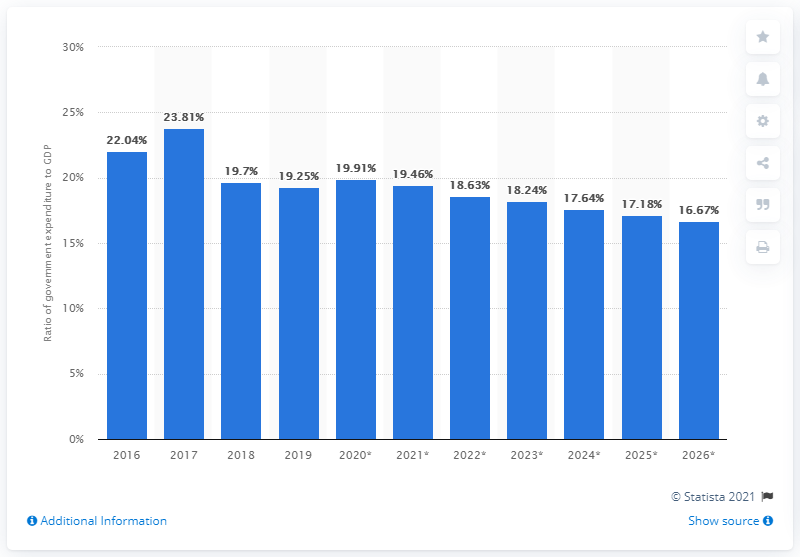List a handful of essential elements in this visual. In 2019, government expenditure in Angola accounted for 19.25% of the country's gross domestic product (GDP). 